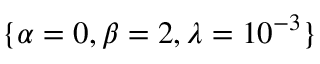Convert formula to latex. <formula><loc_0><loc_0><loc_500><loc_500>\{ \alpha = 0 , \beta = 2 , \lambda = 1 0 ^ { - 3 } \}</formula> 